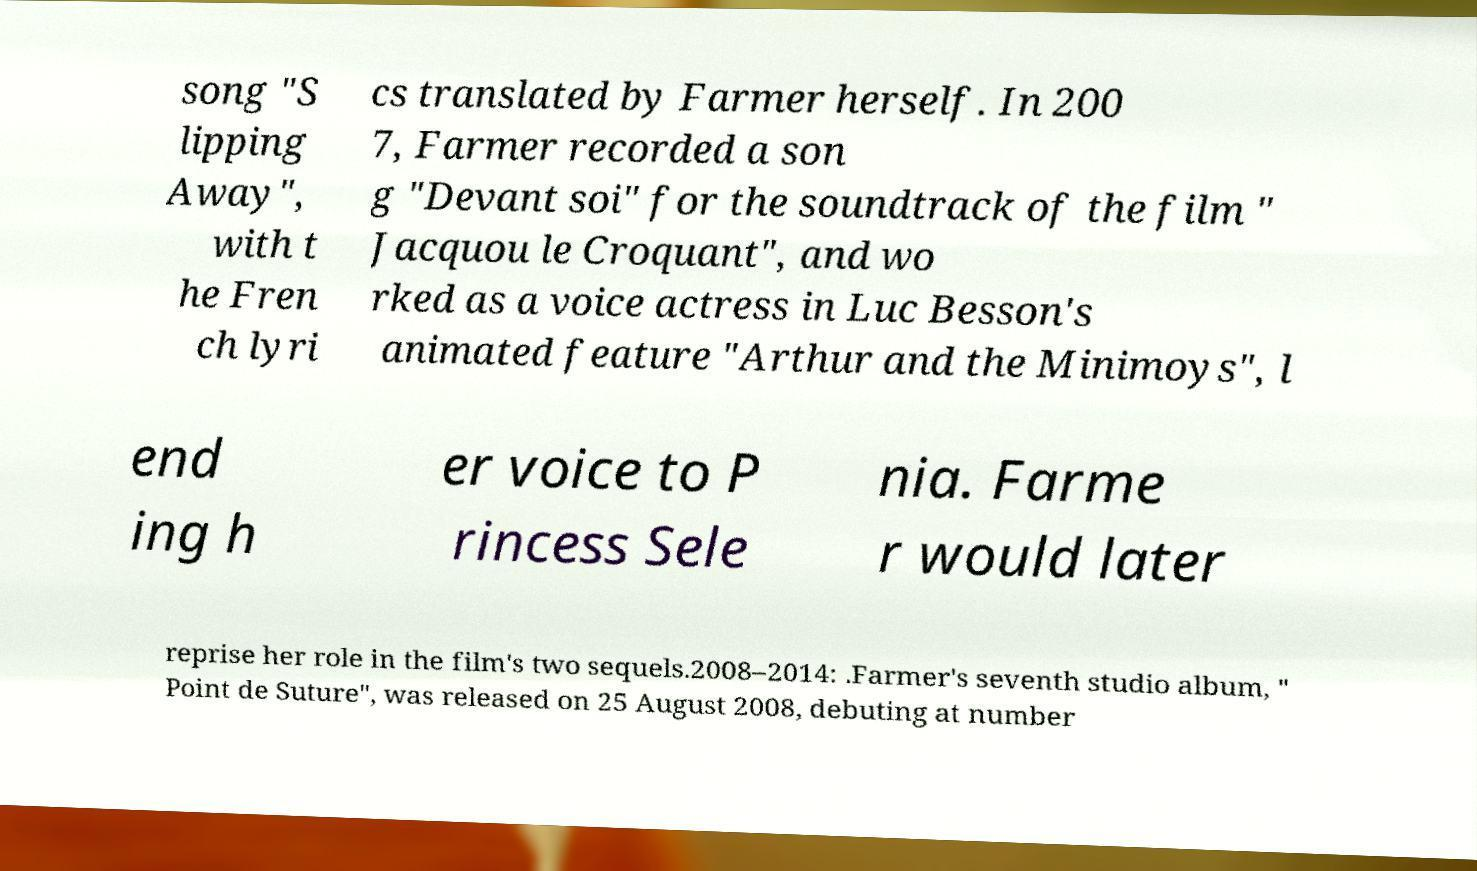Can you accurately transcribe the text from the provided image for me? song "S lipping Away", with t he Fren ch lyri cs translated by Farmer herself. In 200 7, Farmer recorded a son g "Devant soi" for the soundtrack of the film " Jacquou le Croquant", and wo rked as a voice actress in Luc Besson's animated feature "Arthur and the Minimoys", l end ing h er voice to P rincess Sele nia. Farme r would later reprise her role in the film's two sequels.2008–2014: .Farmer's seventh studio album, " Point de Suture", was released on 25 August 2008, debuting at number 